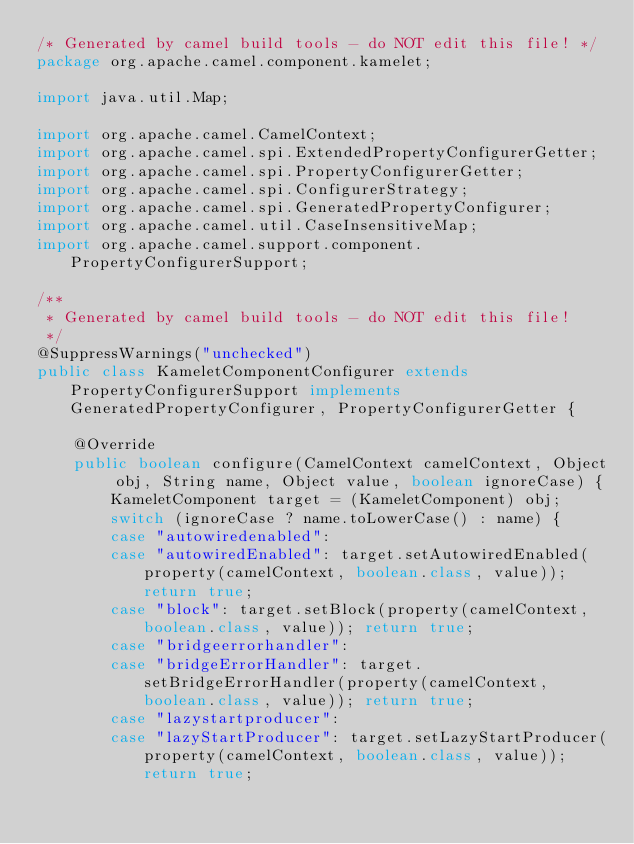Convert code to text. <code><loc_0><loc_0><loc_500><loc_500><_Java_>/* Generated by camel build tools - do NOT edit this file! */
package org.apache.camel.component.kamelet;

import java.util.Map;

import org.apache.camel.CamelContext;
import org.apache.camel.spi.ExtendedPropertyConfigurerGetter;
import org.apache.camel.spi.PropertyConfigurerGetter;
import org.apache.camel.spi.ConfigurerStrategy;
import org.apache.camel.spi.GeneratedPropertyConfigurer;
import org.apache.camel.util.CaseInsensitiveMap;
import org.apache.camel.support.component.PropertyConfigurerSupport;

/**
 * Generated by camel build tools - do NOT edit this file!
 */
@SuppressWarnings("unchecked")
public class KameletComponentConfigurer extends PropertyConfigurerSupport implements GeneratedPropertyConfigurer, PropertyConfigurerGetter {

    @Override
    public boolean configure(CamelContext camelContext, Object obj, String name, Object value, boolean ignoreCase) {
        KameletComponent target = (KameletComponent) obj;
        switch (ignoreCase ? name.toLowerCase() : name) {
        case "autowiredenabled":
        case "autowiredEnabled": target.setAutowiredEnabled(property(camelContext, boolean.class, value)); return true;
        case "block": target.setBlock(property(camelContext, boolean.class, value)); return true;
        case "bridgeerrorhandler":
        case "bridgeErrorHandler": target.setBridgeErrorHandler(property(camelContext, boolean.class, value)); return true;
        case "lazystartproducer":
        case "lazyStartProducer": target.setLazyStartProducer(property(camelContext, boolean.class, value)); return true;</code> 